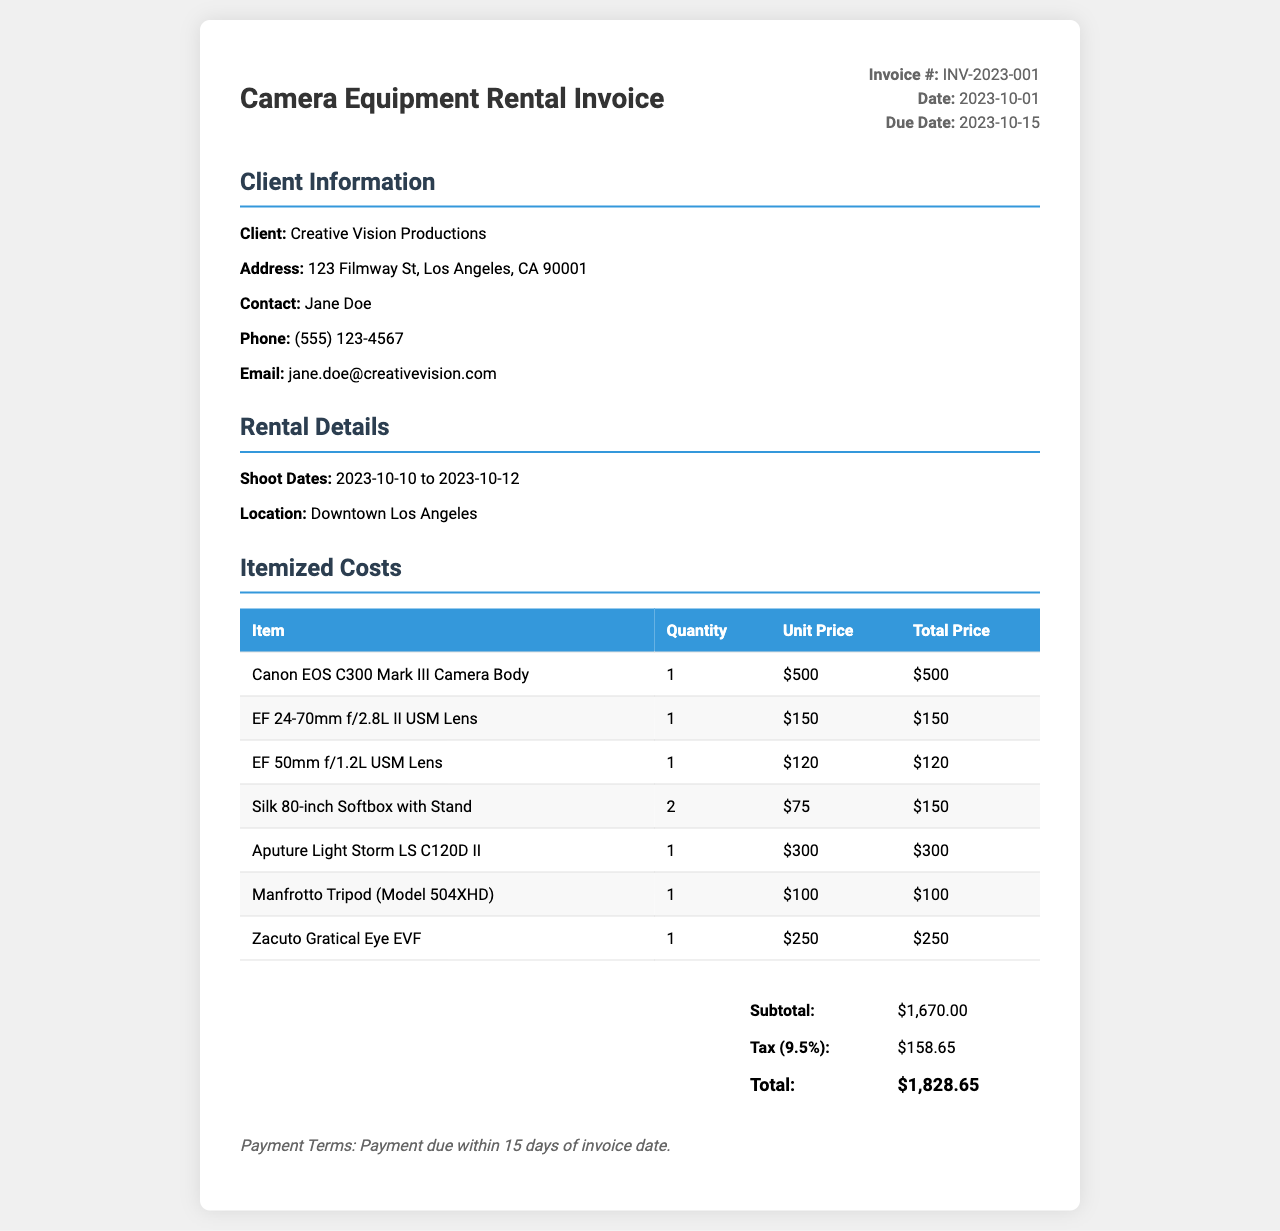What is the invoice number? The invoice number is located in the header of the document and is labeled clearly.
Answer: INV-2023-001 What is the total price for the rental? The total price is calculated from the subtotal and tax, shown in the total section of the invoice.
Answer: $1,828.65 What are the shoot dates? The shoot dates are specified in the rental details section of the invoice.
Answer: 2023-10-10 to 2023-10-12 How much is the tax rate applied? The tax rate is mentioned alongside the tax calculation in the total section.
Answer: 9.5% Who is the client? The client's name is provided in the client information section at the top of the invoice.
Answer: Creative Vision Productions What is the unit price of the Canon EOS C300 Mark III Camera Body? The unit price is provided in the itemized costs table for this specific item.
Answer: $500 What is the subtotal amount? The subtotal is listed in the total section and refers to the sum of all itemized costs before tax.
Answer: $1,670.00 What accessories are included with the rental? Accessories can be identified in the items table under the itemized costs.
Answer: Softbox, Tripod, EVF When is the payment due? The payment due date is indicated in the header of the invoice.
Answer: 2023-10-15 